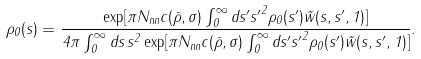Convert formula to latex. <formula><loc_0><loc_0><loc_500><loc_500>\rho _ { 0 } ( s ) = \frac { \exp [ \pi N _ { n n } c ( \bar { \rho } , \sigma ) \int _ { 0 } ^ { \infty } d s ^ { \prime } { s ^ { \prime } } ^ { 2 } \rho _ { 0 } ( s ^ { \prime } ) \tilde { w } ( s , s ^ { \prime } , 1 ) ] } { 4 \pi \int _ { 0 } ^ { \infty } d s \, s ^ { 2 } \exp [ \pi N _ { n n } c ( \bar { \rho } , \sigma ) \int _ { 0 } ^ { \infty } d s ^ { \prime } { s ^ { \prime } } ^ { 2 } \rho _ { 0 } ( s ^ { \prime } ) \tilde { w } ( s , s ^ { \prime } , 1 ) ] } .</formula> 